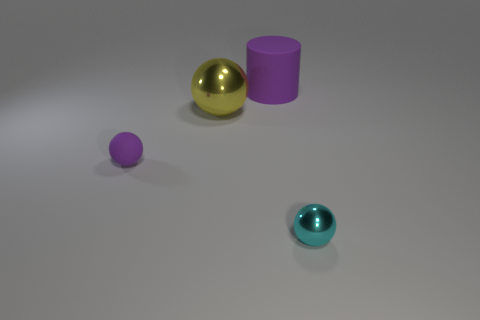How would you describe the arrangement of objects in this image? The objects are arranged sparsely with ample space between them. The composition includes a large yellow sphere, a smaller purple sphere, a purple cylinder, and a smaller teal sphere, all resting on a flat neutral surface lit from above. 